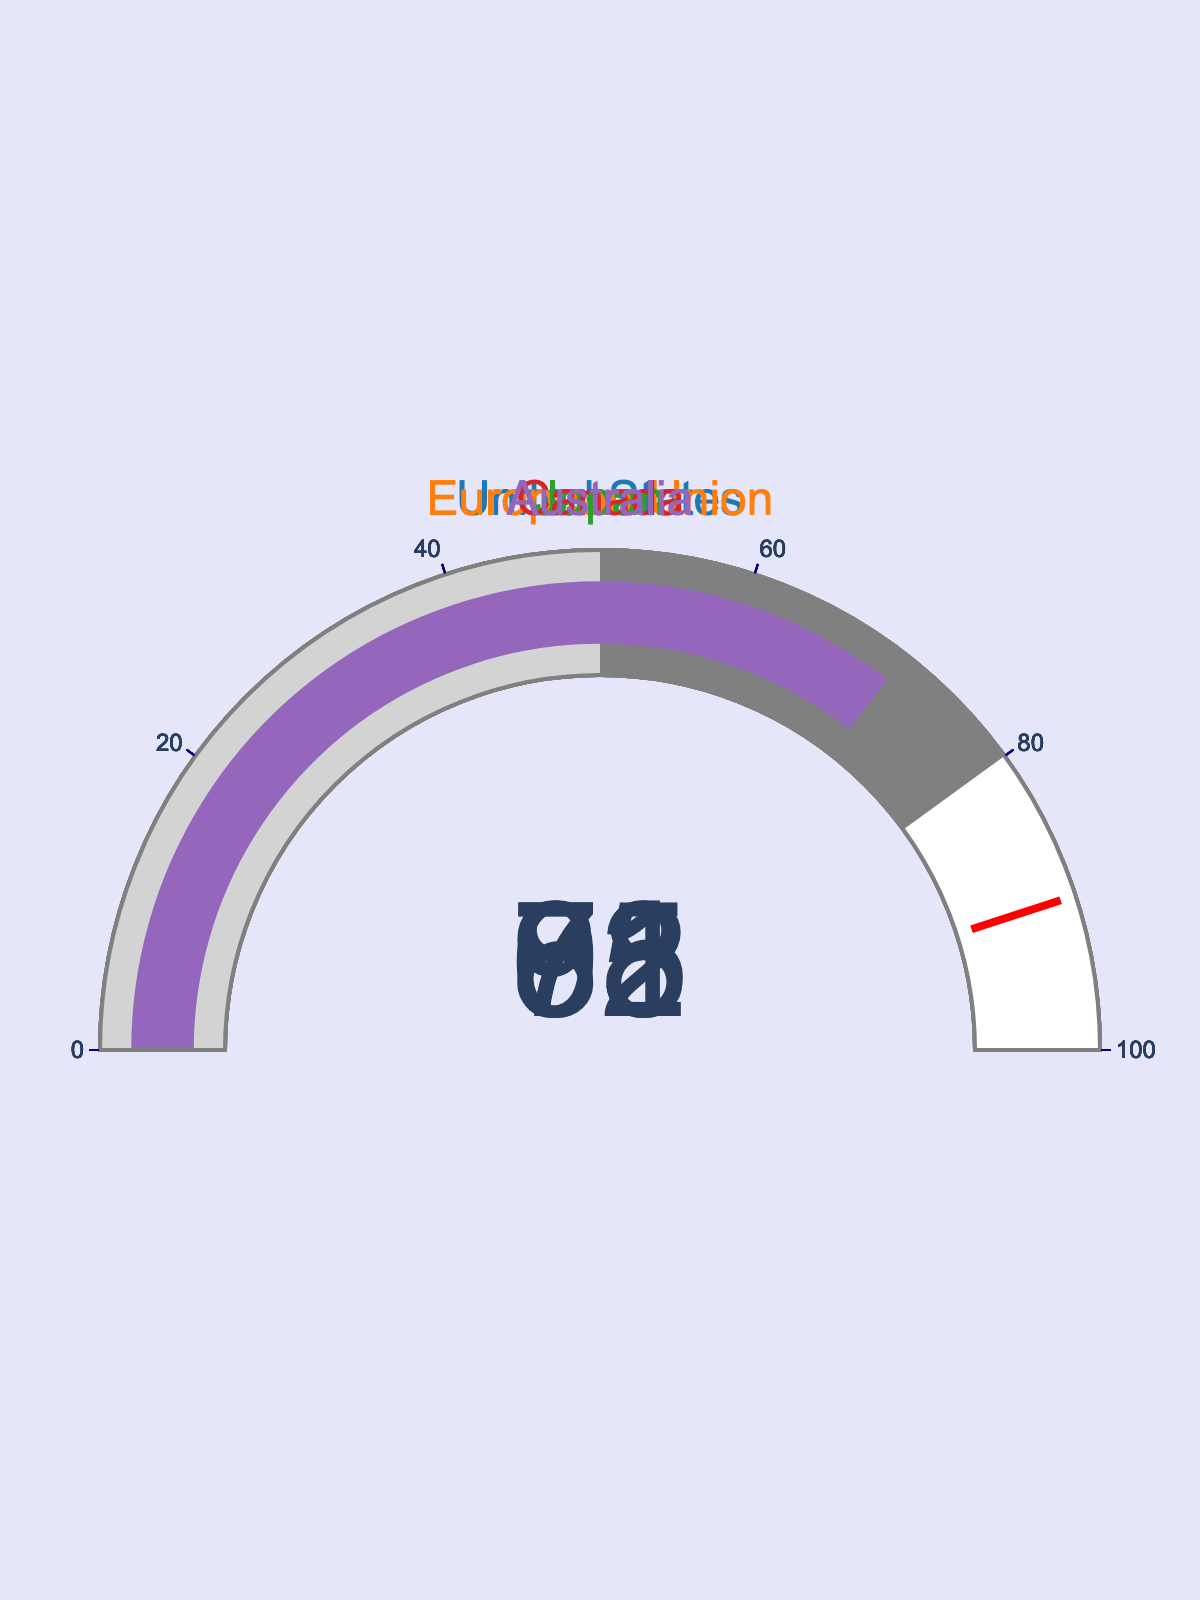Which country has the highest percentage of cross-border data transfers with privacy agreements? Look at the gauge charts and identify the country with the highest value displayed, which is 92.
Answer: European Union Which countries have a percentage of cross-border data transfers with privacy agreements below 70%? Look at the gauge charts and check for values below 70.
Answer: Japan, Australia What's the average percentage of cross-border data transfers with privacy agreements across all countries? Sum the percentages (78 + 92 + 65 + 83 + 71) = 389 and divide by the number of countries (5). 389/5 = 77.8
Answer: 77.8 How does Canada's percentage of cross-border data transfers compare to Australia's? Look at Canada's gauge value (83) and Australia's gauge value (71).
Answer: Canada is higher Which country is closest to reaching the privacy agreement threshold of 90%? Compare the percentages of the countries to 90% and identify the closest one, which is 92.
Answer: European Union If the threshold of privacy agreements were lowered to 80%, which additional countries would be included? Check which countries have percentages below 90% but above 80%.
Answer: Canada, United States Is Japan’s percentage of cross-border data transfers closer to 50% or 100%? Compare Japan's percentage (65) to 50 and 100.
Answer: Closer to 50% What's the difference in the percentage of cross-border data transfers between the United States and Japan? Subtract Japan's percentage (65) from the United States’ percentage (78). 78 - 65 = 13
Answer: 13 If you were to rank the countries based on their percentage of cross-border data transfers, what would be Japan’s rank? Order the countries by their percentages: (92, 83, 78, 71, 65). Japan is last (5th).
Answer: 5th 